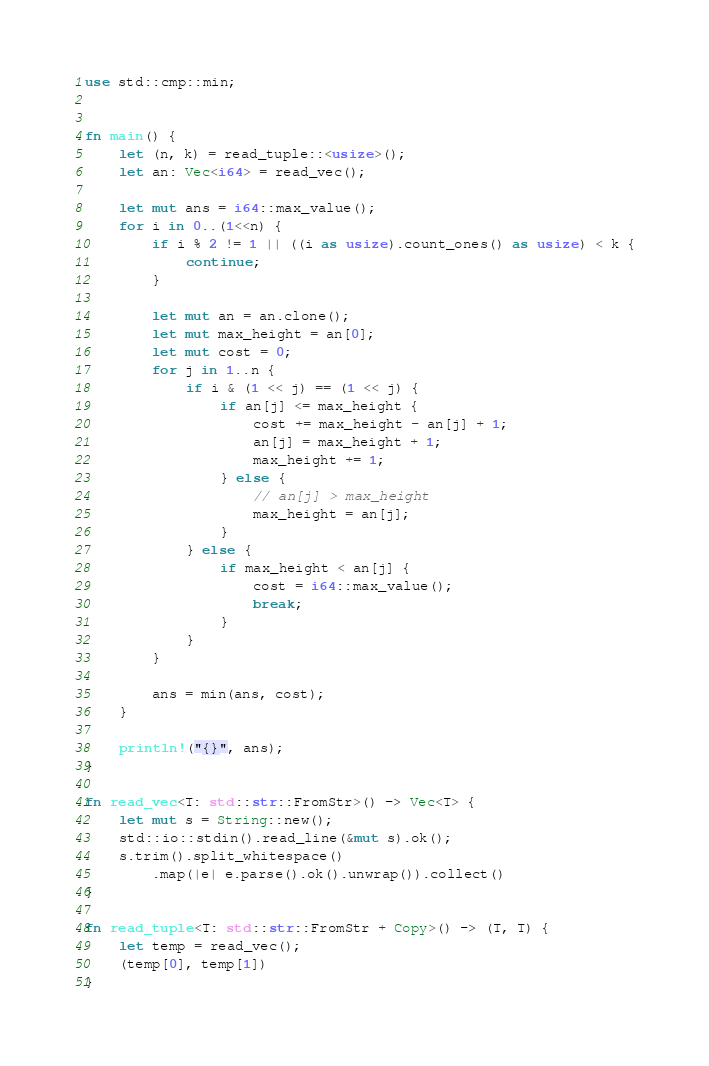<code> <loc_0><loc_0><loc_500><loc_500><_Rust_>use std::cmp::min;


fn main() {
    let (n, k) = read_tuple::<usize>();
    let an: Vec<i64> = read_vec();

    let mut ans = i64::max_value();
    for i in 0..(1<<n) {
        if i % 2 != 1 || ((i as usize).count_ones() as usize) < k {
            continue;
        }

        let mut an = an.clone();
        let mut max_height = an[0];
        let mut cost = 0;
        for j in 1..n {
            if i & (1 << j) == (1 << j) {
                if an[j] <= max_height {
                    cost += max_height - an[j] + 1;
                    an[j] = max_height + 1;
                    max_height += 1;
                } else {
                    // an[j] > max_height
                    max_height = an[j];
                }
            } else {
                if max_height < an[j] {
                    cost = i64::max_value();
                    break;
                }
            }
        }

        ans = min(ans, cost);
    }

    println!("{}", ans);
}

fn read_vec<T: std::str::FromStr>() -> Vec<T> {
    let mut s = String::new();
    std::io::stdin().read_line(&mut s).ok();
    s.trim().split_whitespace()
        .map(|e| e.parse().ok().unwrap()).collect()
}

fn read_tuple<T: std::str::FromStr + Copy>() -> (T, T) {
    let temp = read_vec();
    (temp[0], temp[1])
}
</code> 